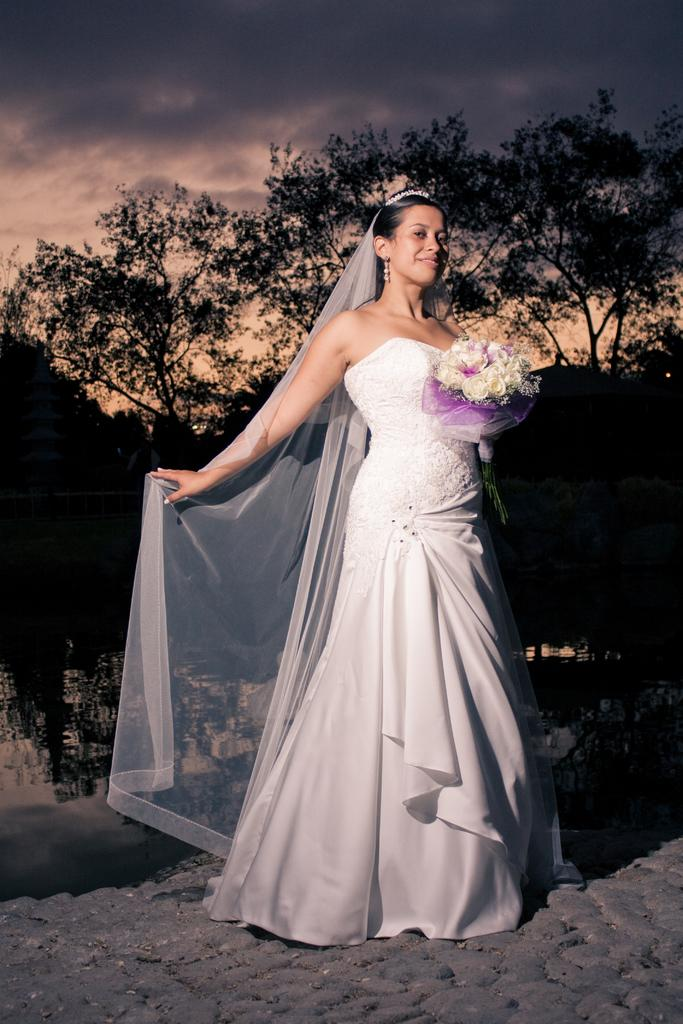Who is present in the image? There is a woman in the image. What is the woman wearing? The woman is wearing a white frock. What is the woman holding in the image? The woman is holding a white flower bouquet. What can be seen in the background of the image? There are trees in the background of the image. How would you describe the sky in the image? The sky appears to be dark in the image. How many owls can be seen in the image? There are no owls present in the image. What type of cellar is visible in the image? There is no cellar present in the image. 